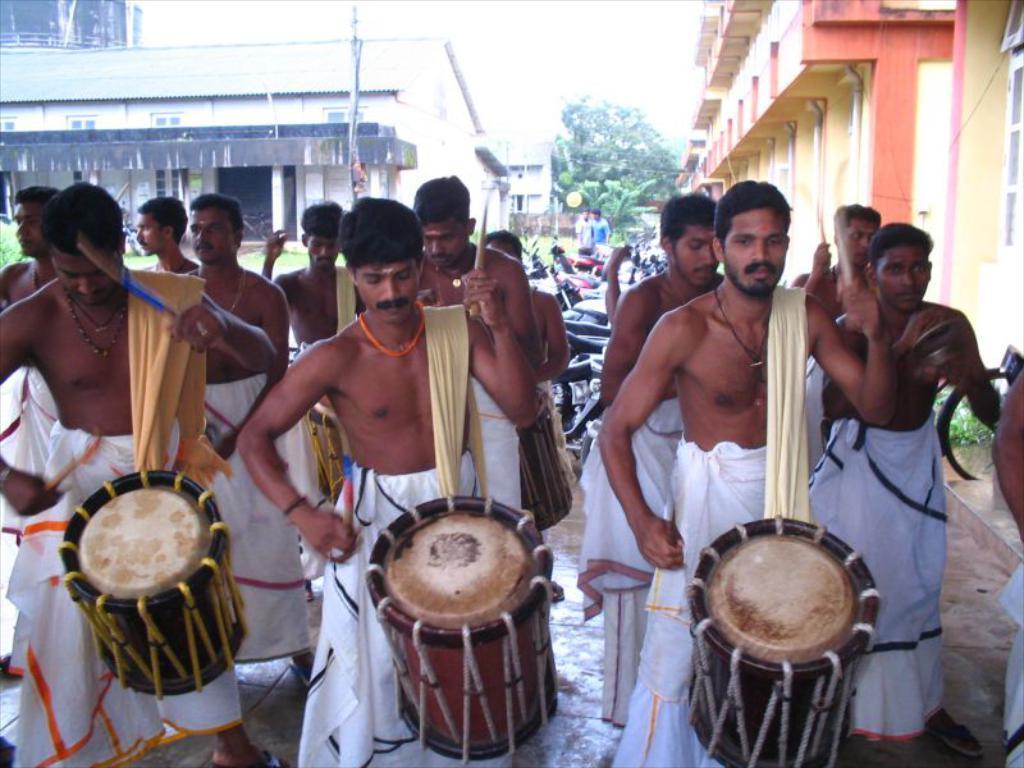Could you give a brief overview of what you see in this image? In this image we can see a group of people standing holding the drums and sticks. On the backside we can see some buildings with windows, some motor vehicles parked aside, a pole, grass, trees and the sky. 